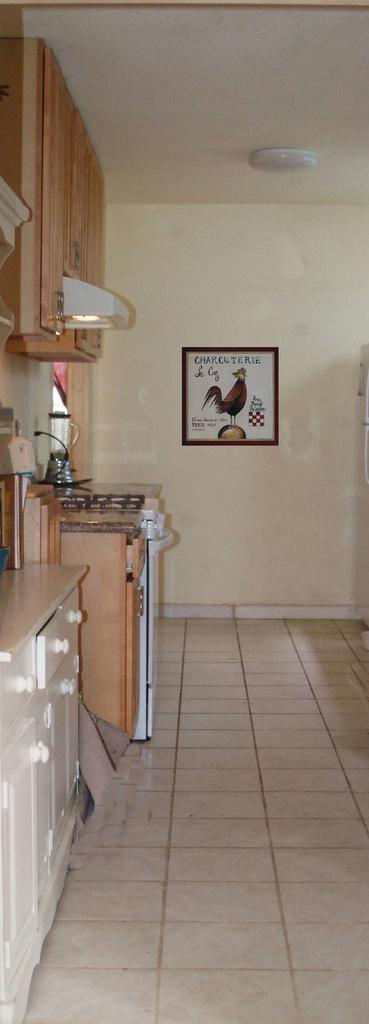What type of space is shown in the image? The image is an inside view of a room. Where are the cupboards located in the room? The cupboards are on the left side of the room. What type of furniture is present in the room? There is a drawer in the room. What architectural feature is present in the room? There is a chimney in the room. What can be found in the room besides furniture and architectural features? There are objects in the room. What is hanging on the wall in the background? There is a frame on the wall in the background. What type of lighting is present in the room? There is a light on the ceiling in the background. What type of fruit is sitting on the dad's toothbrush in the image? There is no dad or toothbrush present in the image, and therefore no fruit can be found on a toothbrush. 